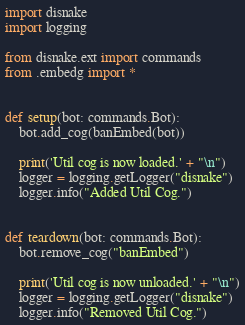Convert code to text. <code><loc_0><loc_0><loc_500><loc_500><_Python_>import disnake
import logging

from disnake.ext import commands
from .embedg import *


def setup(bot: commands.Bot):
    bot.add_cog(banEmbed(bot))

    print('Util cog is now loaded.' + "\n")
    logger = logging.getLogger("disnake")
    logger.info("Added Util Cog.")


def teardown(bot: commands.Bot):
    bot.remove_cog("banEmbed")

    print('Util cog is now unloaded.' + "\n")
    logger = logging.getLogger("disnake")
    logger.info("Removed Util Cog.")</code> 